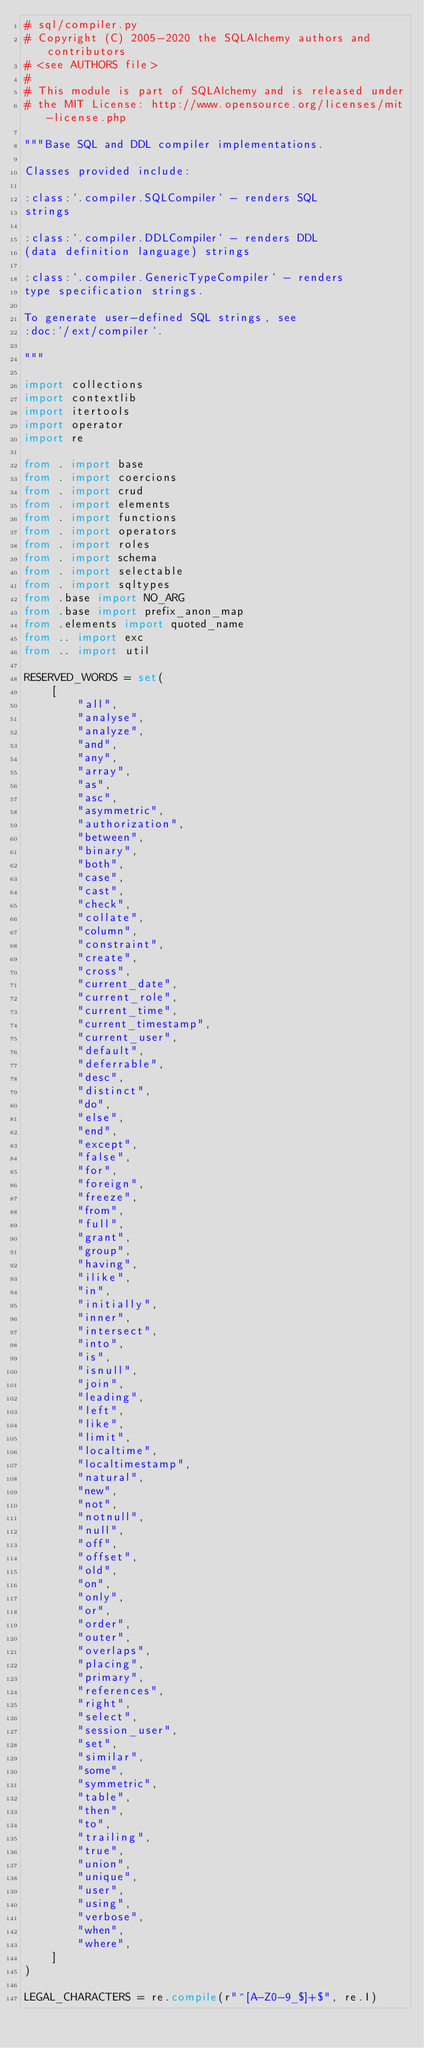<code> <loc_0><loc_0><loc_500><loc_500><_Python_># sql/compiler.py
# Copyright (C) 2005-2020 the SQLAlchemy authors and contributors
# <see AUTHORS file>
#
# This module is part of SQLAlchemy and is released under
# the MIT License: http://www.opensource.org/licenses/mit-license.php

"""Base SQL and DDL compiler implementations.

Classes provided include:

:class:`.compiler.SQLCompiler` - renders SQL
strings

:class:`.compiler.DDLCompiler` - renders DDL
(data definition language) strings

:class:`.compiler.GenericTypeCompiler` - renders
type specification strings.

To generate user-defined SQL strings, see
:doc:`/ext/compiler`.

"""

import collections
import contextlib
import itertools
import operator
import re

from . import base
from . import coercions
from . import crud
from . import elements
from . import functions
from . import operators
from . import roles
from . import schema
from . import selectable
from . import sqltypes
from .base import NO_ARG
from .base import prefix_anon_map
from .elements import quoted_name
from .. import exc
from .. import util

RESERVED_WORDS = set(
    [
        "all",
        "analyse",
        "analyze",
        "and",
        "any",
        "array",
        "as",
        "asc",
        "asymmetric",
        "authorization",
        "between",
        "binary",
        "both",
        "case",
        "cast",
        "check",
        "collate",
        "column",
        "constraint",
        "create",
        "cross",
        "current_date",
        "current_role",
        "current_time",
        "current_timestamp",
        "current_user",
        "default",
        "deferrable",
        "desc",
        "distinct",
        "do",
        "else",
        "end",
        "except",
        "false",
        "for",
        "foreign",
        "freeze",
        "from",
        "full",
        "grant",
        "group",
        "having",
        "ilike",
        "in",
        "initially",
        "inner",
        "intersect",
        "into",
        "is",
        "isnull",
        "join",
        "leading",
        "left",
        "like",
        "limit",
        "localtime",
        "localtimestamp",
        "natural",
        "new",
        "not",
        "notnull",
        "null",
        "off",
        "offset",
        "old",
        "on",
        "only",
        "or",
        "order",
        "outer",
        "overlaps",
        "placing",
        "primary",
        "references",
        "right",
        "select",
        "session_user",
        "set",
        "similar",
        "some",
        "symmetric",
        "table",
        "then",
        "to",
        "trailing",
        "true",
        "union",
        "unique",
        "user",
        "using",
        "verbose",
        "when",
        "where",
    ]
)

LEGAL_CHARACTERS = re.compile(r"^[A-Z0-9_$]+$", re.I)</code> 